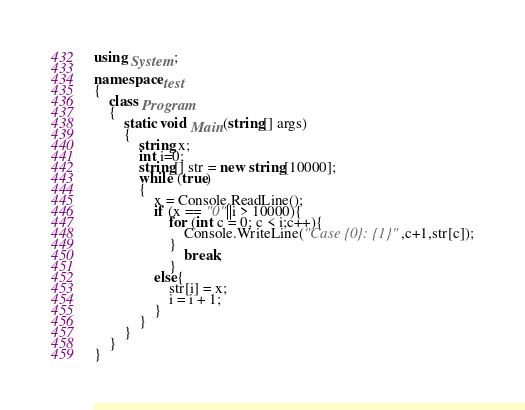<code> <loc_0><loc_0><loc_500><loc_500><_C#_>using System;

namespace test
{
    class Program
    {
        static void Main(string[] args)
        {
            string x;
            int i=0;
            string[] str = new string[10000];
            while (true)
            {
                x = Console.ReadLine();
                if (x == "0"||i > 10000){
                    for (int c = 0; c < i;c++){
                        Console.WriteLine("Case {0}: {1}",c+1,str[c]);
                    }
                        break;
                    }
                else{
                    str[i] = x;
                    i = i + 1;
                }
            }
        }
    }
}</code> 